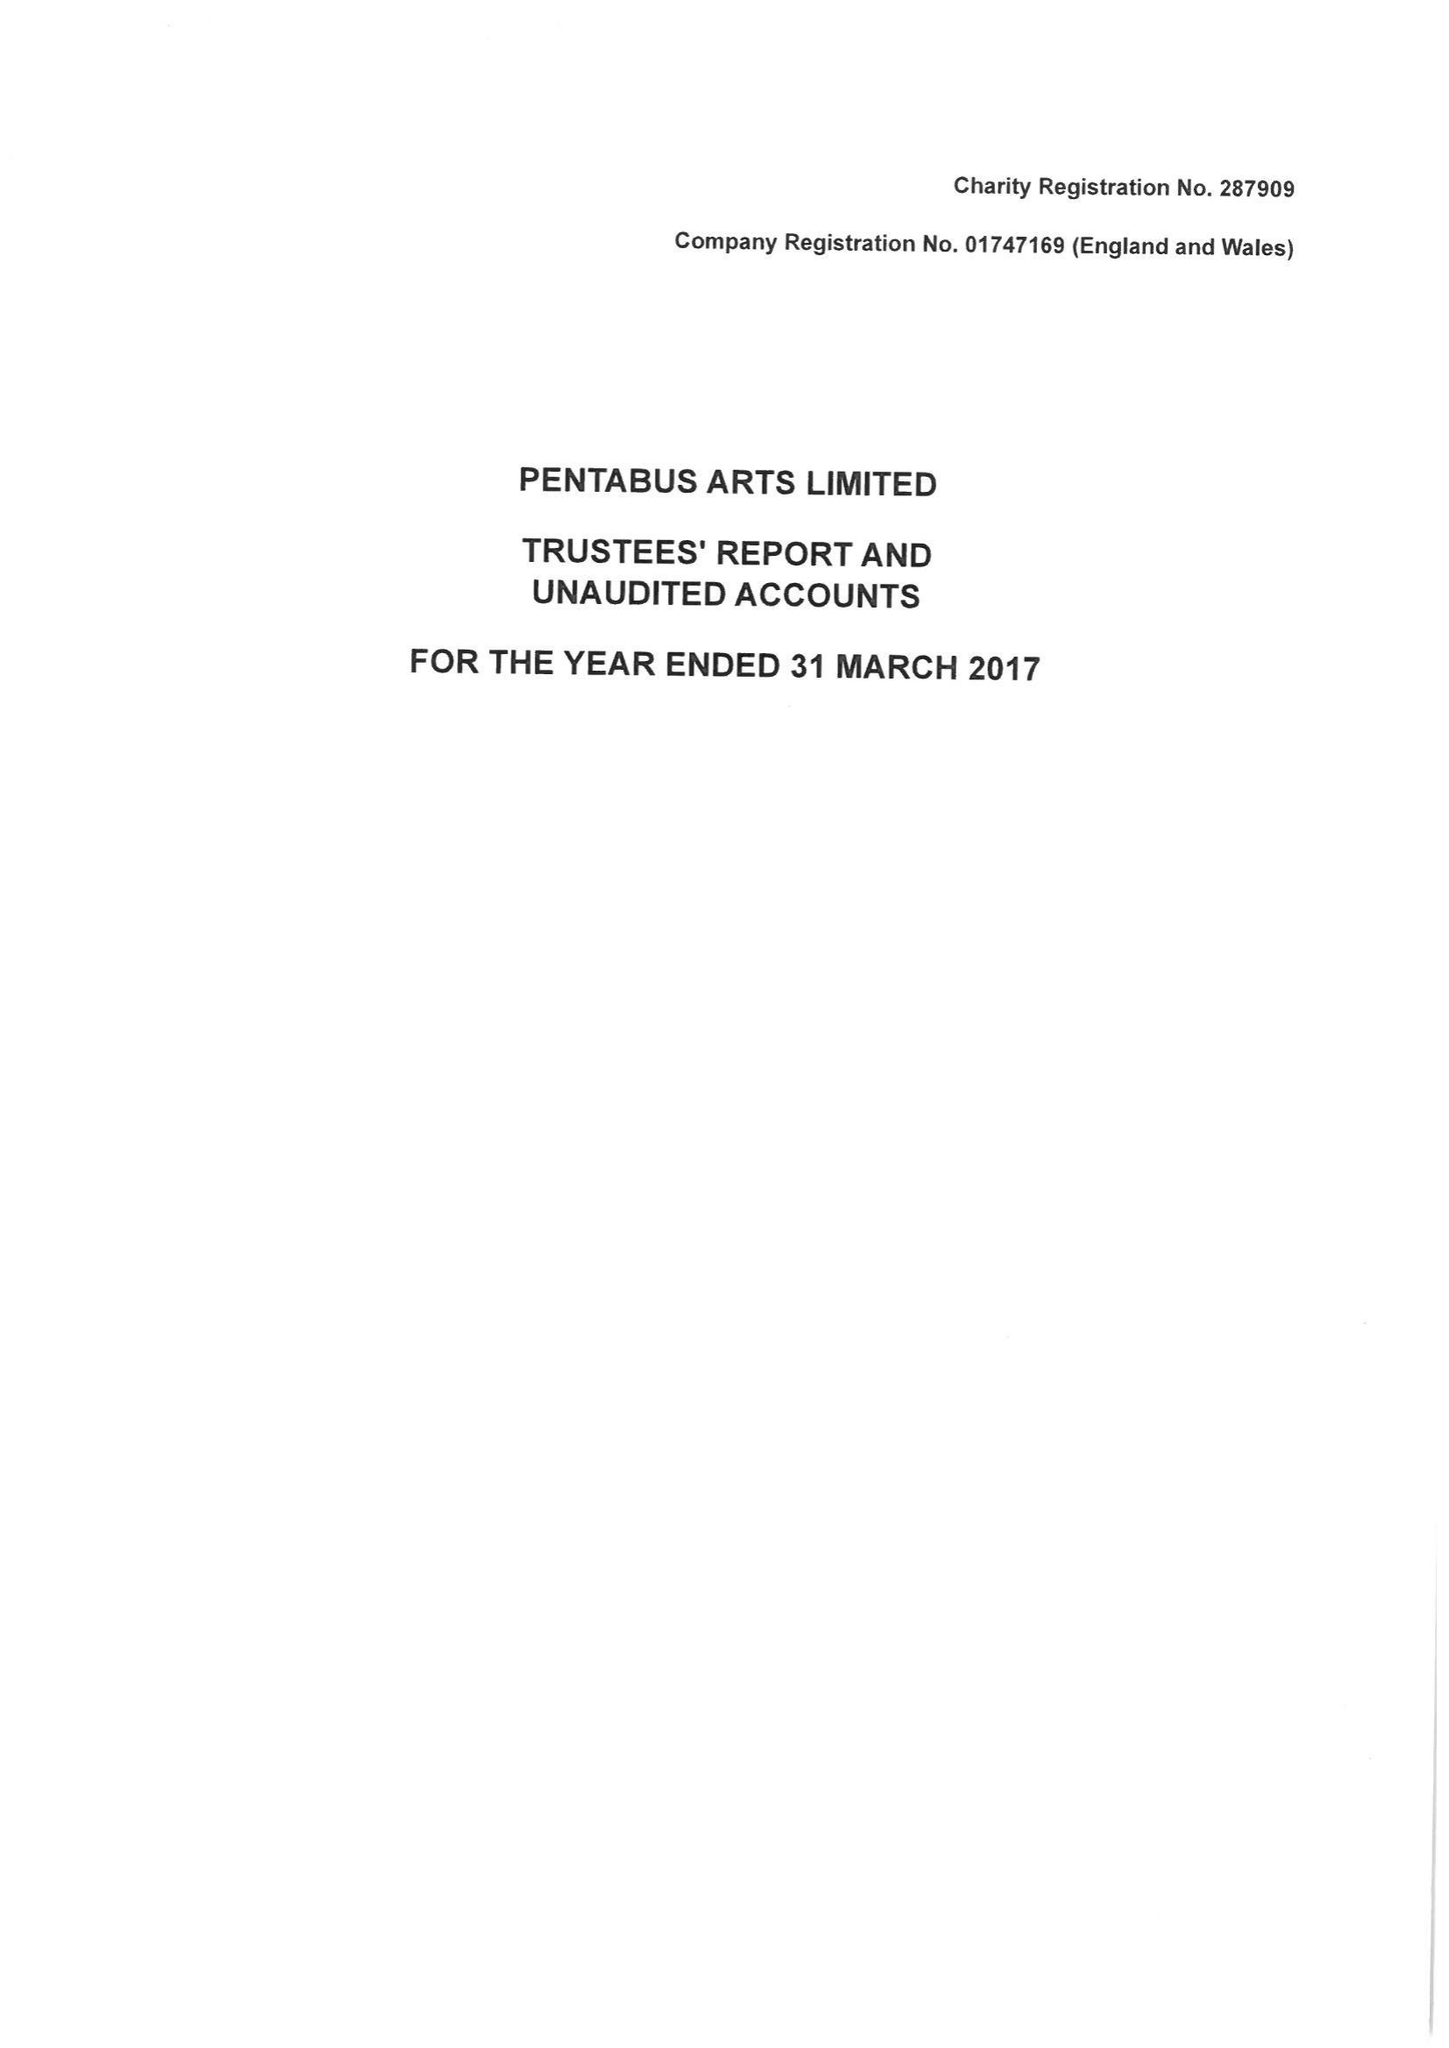What is the value for the charity_name?
Answer the question using a single word or phrase. Pentabus Arts Ltd. 